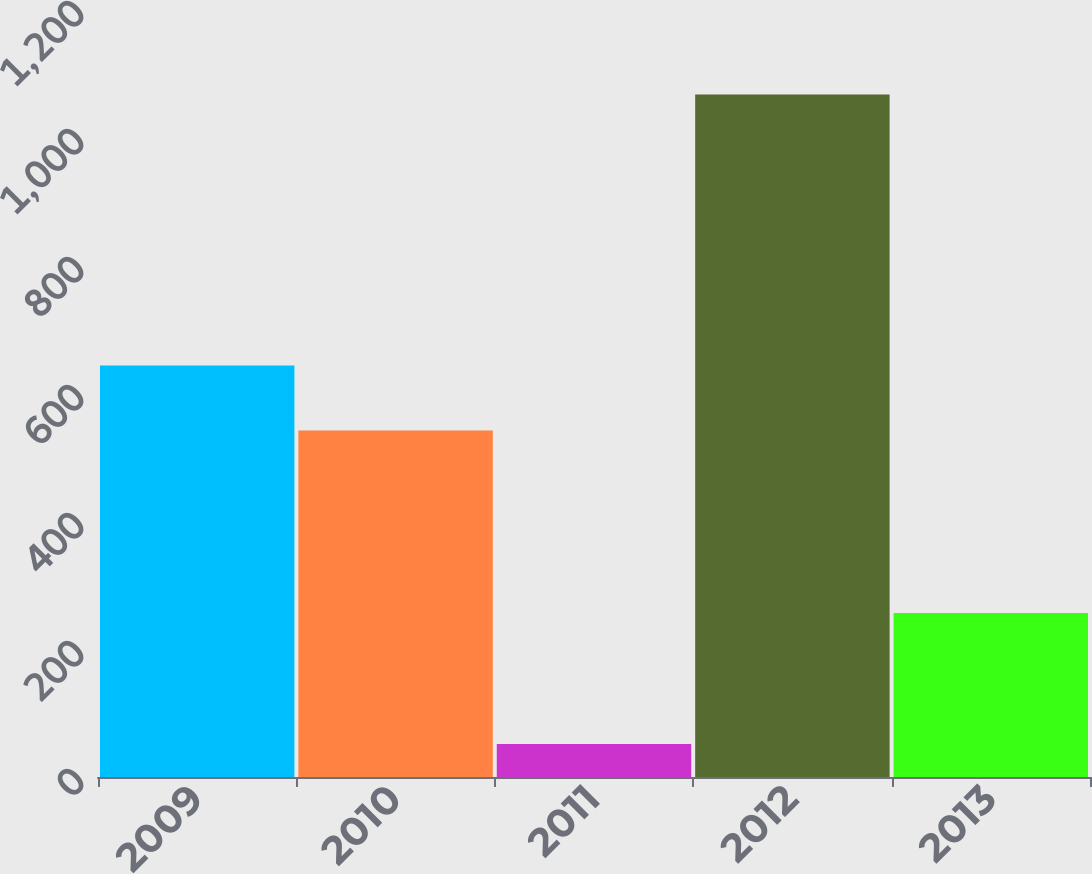<chart> <loc_0><loc_0><loc_500><loc_500><bar_chart><fcel>2009<fcel>2010<fcel>2011<fcel>2012<fcel>2013<nl><fcel>643.09<fcel>541.6<fcel>51.5<fcel>1066.4<fcel>256.1<nl></chart> 